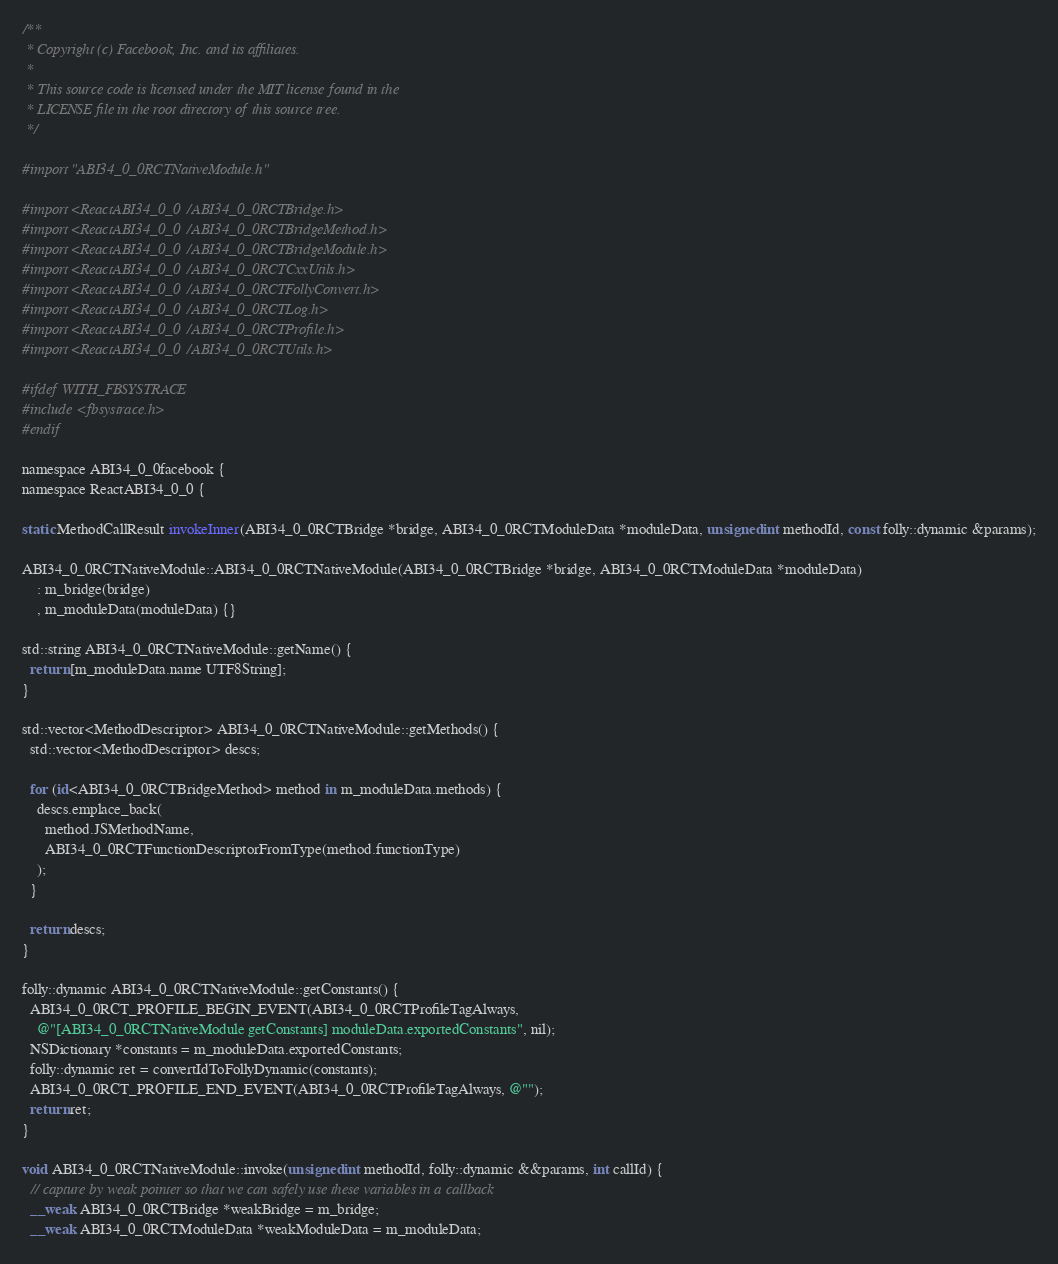Convert code to text. <code><loc_0><loc_0><loc_500><loc_500><_ObjectiveC_>/**
 * Copyright (c) Facebook, Inc. and its affiliates.
 *
 * This source code is licensed under the MIT license found in the
 * LICENSE file in the root directory of this source tree.
 */

#import "ABI34_0_0RCTNativeModule.h"

#import <ReactABI34_0_0/ABI34_0_0RCTBridge.h>
#import <ReactABI34_0_0/ABI34_0_0RCTBridgeMethod.h>
#import <ReactABI34_0_0/ABI34_0_0RCTBridgeModule.h>
#import <ReactABI34_0_0/ABI34_0_0RCTCxxUtils.h>
#import <ReactABI34_0_0/ABI34_0_0RCTFollyConvert.h>
#import <ReactABI34_0_0/ABI34_0_0RCTLog.h>
#import <ReactABI34_0_0/ABI34_0_0RCTProfile.h>
#import <ReactABI34_0_0/ABI34_0_0RCTUtils.h>

#ifdef WITH_FBSYSTRACE
#include <fbsystrace.h>
#endif

namespace ABI34_0_0facebook {
namespace ReactABI34_0_0 {

static MethodCallResult invokeInner(ABI34_0_0RCTBridge *bridge, ABI34_0_0RCTModuleData *moduleData, unsigned int methodId, const folly::dynamic &params);

ABI34_0_0RCTNativeModule::ABI34_0_0RCTNativeModule(ABI34_0_0RCTBridge *bridge, ABI34_0_0RCTModuleData *moduleData)
    : m_bridge(bridge)
    , m_moduleData(moduleData) {}

std::string ABI34_0_0RCTNativeModule::getName() {
  return [m_moduleData.name UTF8String];
}

std::vector<MethodDescriptor> ABI34_0_0RCTNativeModule::getMethods() {
  std::vector<MethodDescriptor> descs;

  for (id<ABI34_0_0RCTBridgeMethod> method in m_moduleData.methods) {
    descs.emplace_back(
      method.JSMethodName,
      ABI34_0_0RCTFunctionDescriptorFromType(method.functionType)
    );
  }

  return descs;
}

folly::dynamic ABI34_0_0RCTNativeModule::getConstants() {
  ABI34_0_0RCT_PROFILE_BEGIN_EVENT(ABI34_0_0RCTProfileTagAlways,
    @"[ABI34_0_0RCTNativeModule getConstants] moduleData.exportedConstants", nil);
  NSDictionary *constants = m_moduleData.exportedConstants;
  folly::dynamic ret = convertIdToFollyDynamic(constants);
  ABI34_0_0RCT_PROFILE_END_EVENT(ABI34_0_0RCTProfileTagAlways, @"");
  return ret;
}

void ABI34_0_0RCTNativeModule::invoke(unsigned int methodId, folly::dynamic &&params, int callId) {
  // capture by weak pointer so that we can safely use these variables in a callback
  __weak ABI34_0_0RCTBridge *weakBridge = m_bridge;
  __weak ABI34_0_0RCTModuleData *weakModuleData = m_moduleData;</code> 